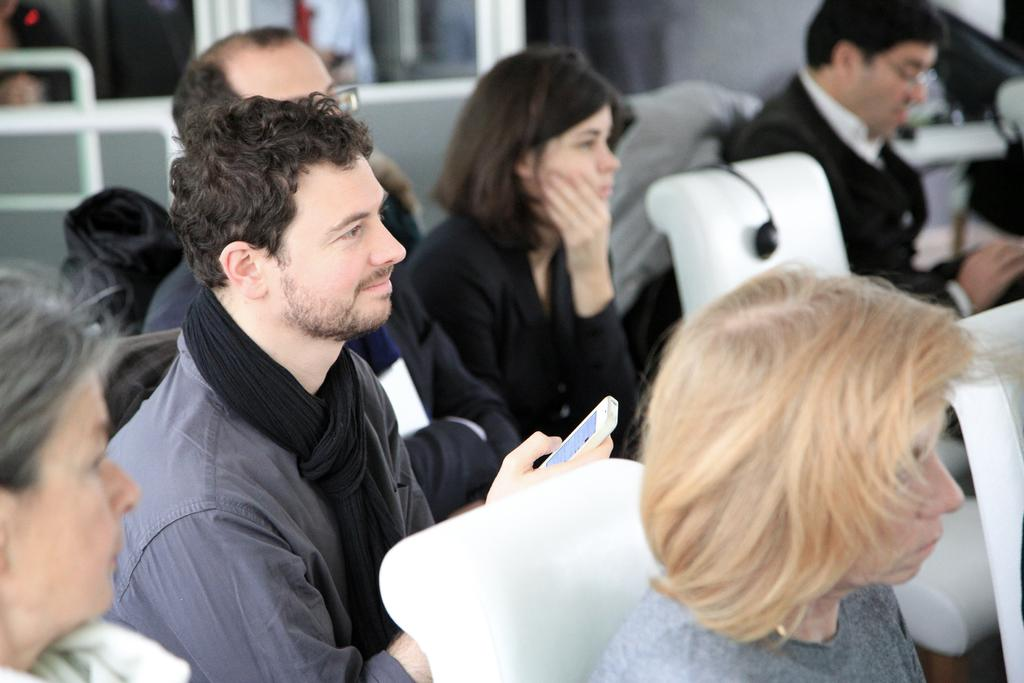What are the people in the image doing? The persons in the image are sitting on chairs. Can you describe what one of the persons is holding? One person is holding a mobile in the image. What object is placed on a chair in the image? There is a headset on a chair in the image. What type of eggs can be seen being used to knit a scarf in the image? There are no eggs or knitting activity present in the image. What type of laborer can be seen working in the image? There is no laborer present in the image; it features persons sitting on chairs and holding a mobile. 